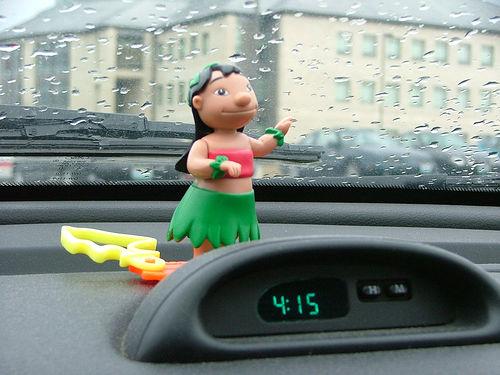What time does the clock say?
Short answer required. 4:15. Is it a sunny day?
Keep it brief. No. What character is on the dashboard?
Concise answer only. Lilo. 